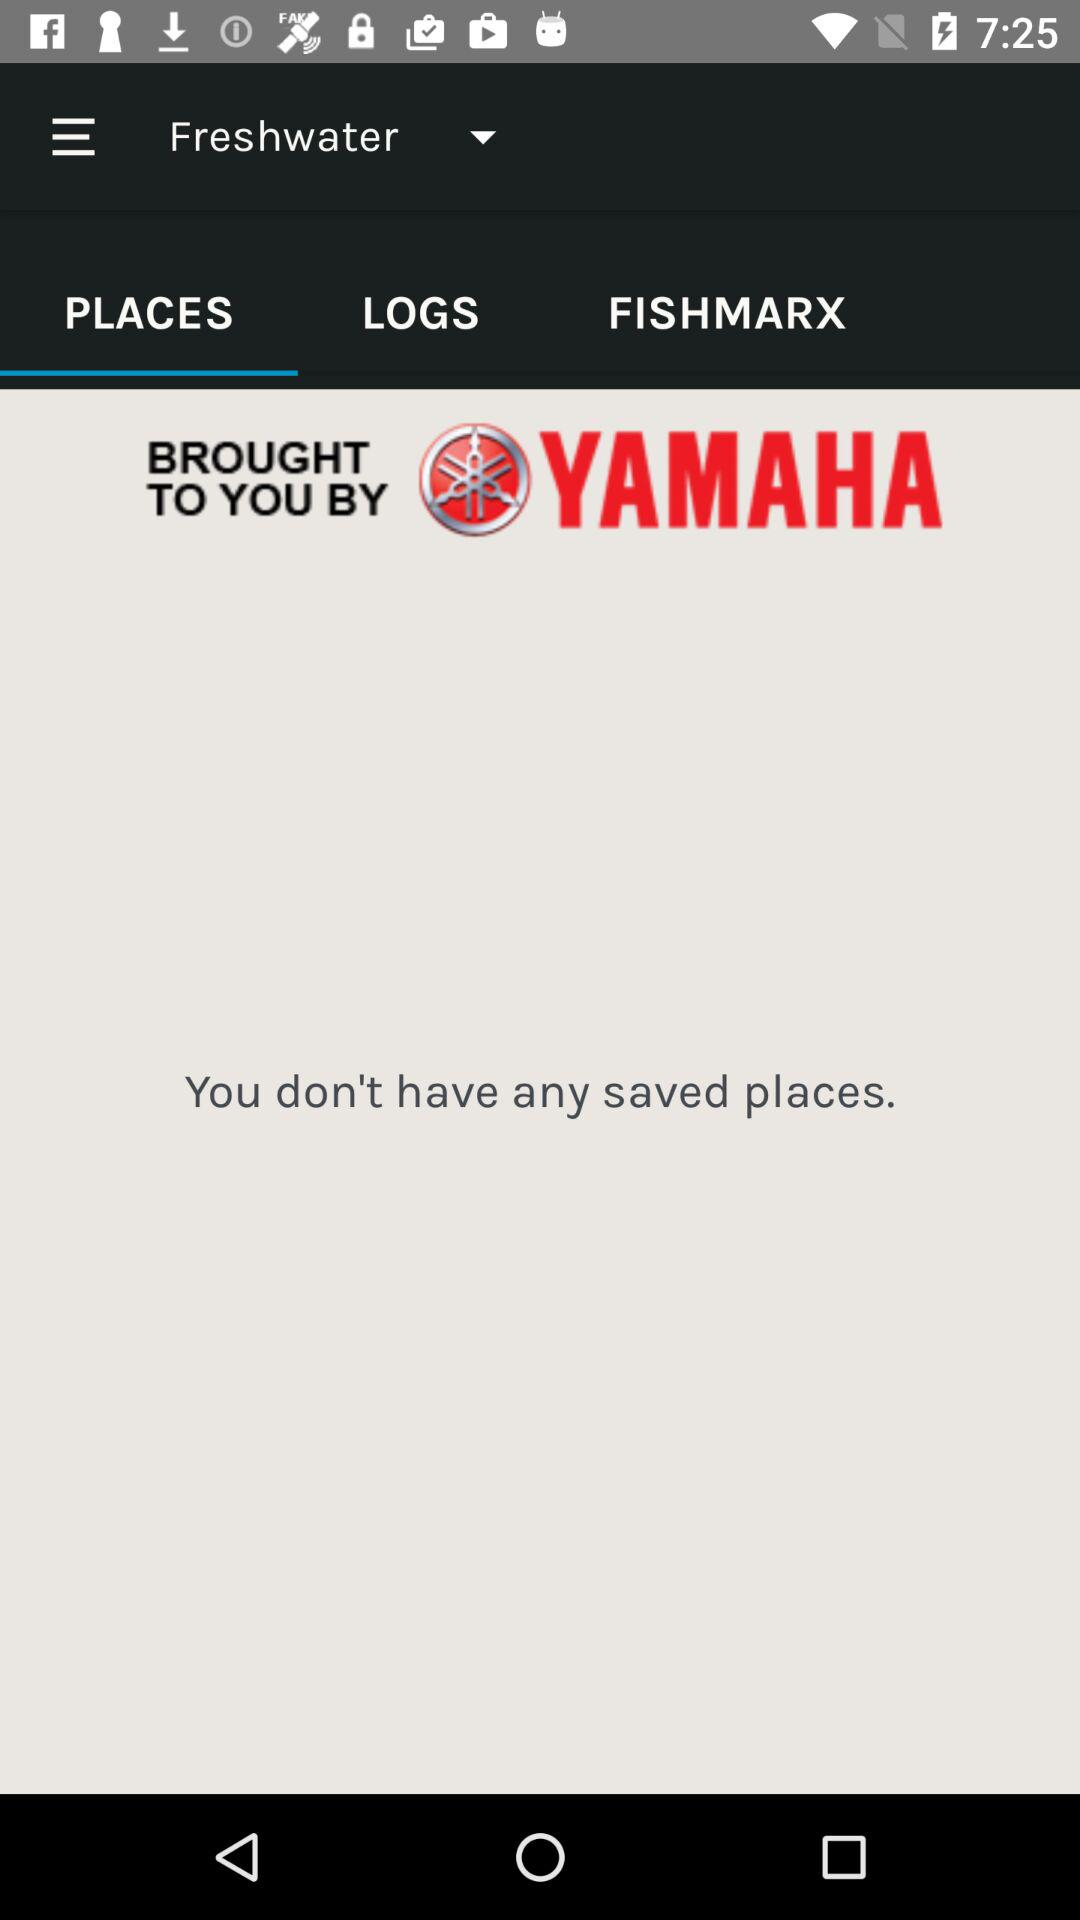Which tab is selected? The selected tab is "PLACES". 